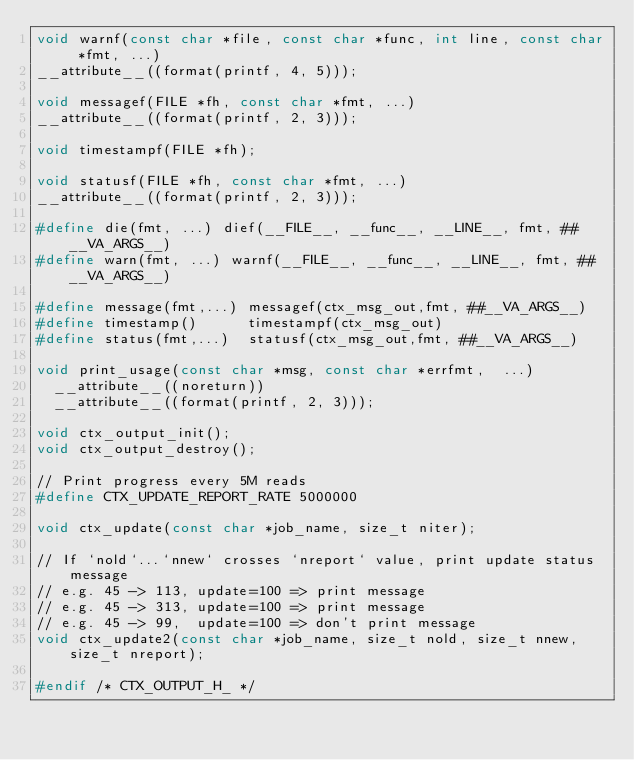<code> <loc_0><loc_0><loc_500><loc_500><_C_>void warnf(const char *file, const char *func, int line, const char *fmt, ...)
__attribute__((format(printf, 4, 5)));

void messagef(FILE *fh, const char *fmt, ...)
__attribute__((format(printf, 2, 3)));

void timestampf(FILE *fh);

void statusf(FILE *fh, const char *fmt, ...)
__attribute__((format(printf, 2, 3)));

#define die(fmt, ...) dief(__FILE__, __func__, __LINE__, fmt, ##__VA_ARGS__)
#define warn(fmt, ...) warnf(__FILE__, __func__, __LINE__, fmt, ##__VA_ARGS__)

#define message(fmt,...) messagef(ctx_msg_out,fmt, ##__VA_ARGS__)
#define timestamp()      timestampf(ctx_msg_out)
#define status(fmt,...)  statusf(ctx_msg_out,fmt, ##__VA_ARGS__)

void print_usage(const char *msg, const char *errfmt,  ...)
  __attribute__((noreturn))
  __attribute__((format(printf, 2, 3)));

void ctx_output_init();
void ctx_output_destroy();

// Print progress every 5M reads
#define CTX_UPDATE_REPORT_RATE 5000000

void ctx_update(const char *job_name, size_t niter);

// If `nold`...`nnew` crosses `nreport` value, print update status message
// e.g. 45 -> 113, update=100 => print message
// e.g. 45 -> 313, update=100 => print message
// e.g. 45 -> 99,  update=100 => don't print message
void ctx_update2(const char *job_name, size_t nold, size_t nnew, size_t nreport);

#endif /* CTX_OUTPUT_H_ */
</code> 